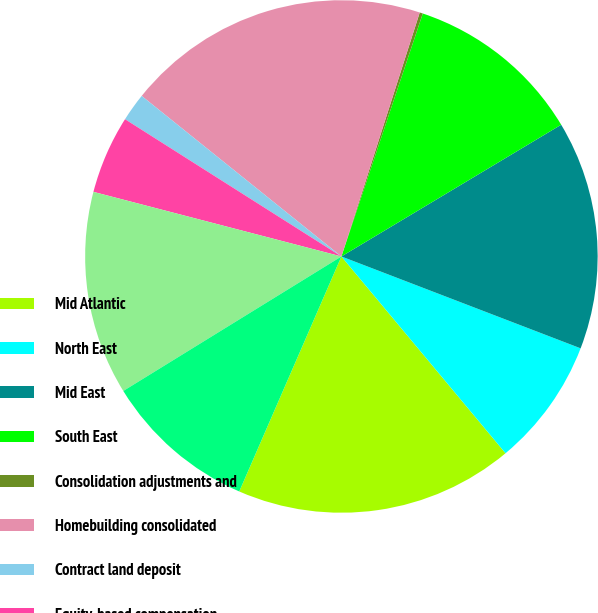Convert chart to OTSL. <chart><loc_0><loc_0><loc_500><loc_500><pie_chart><fcel>Mid Atlantic<fcel>North East<fcel>Mid East<fcel>South East<fcel>Consolidation adjustments and<fcel>Homebuilding consolidated<fcel>Contract land deposit<fcel>Equity-based compensation<fcel>Corporate capital allocation<fcel>Unallocated corporate overhead<nl><fcel>17.59%<fcel>8.1%<fcel>14.43%<fcel>11.26%<fcel>0.2%<fcel>19.17%<fcel>1.78%<fcel>4.94%<fcel>12.85%<fcel>9.68%<nl></chart> 